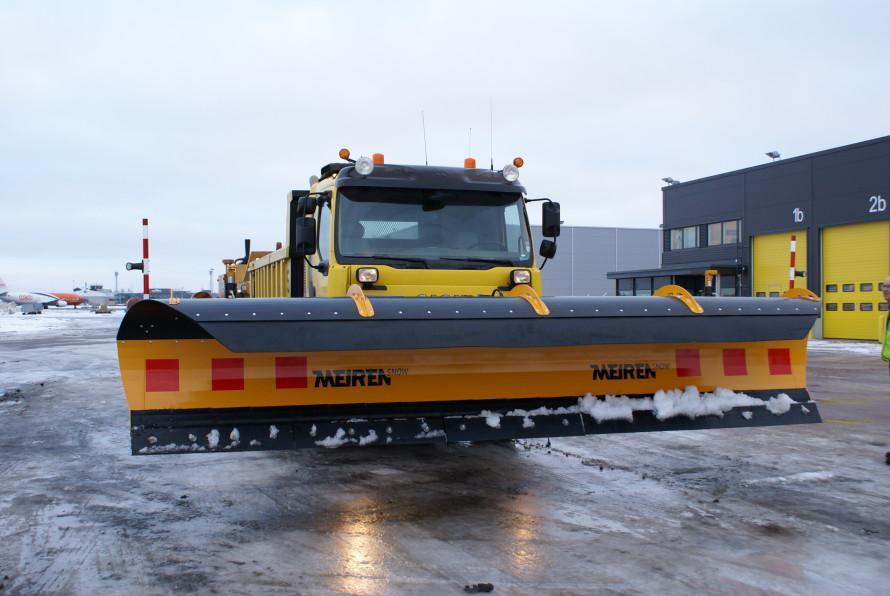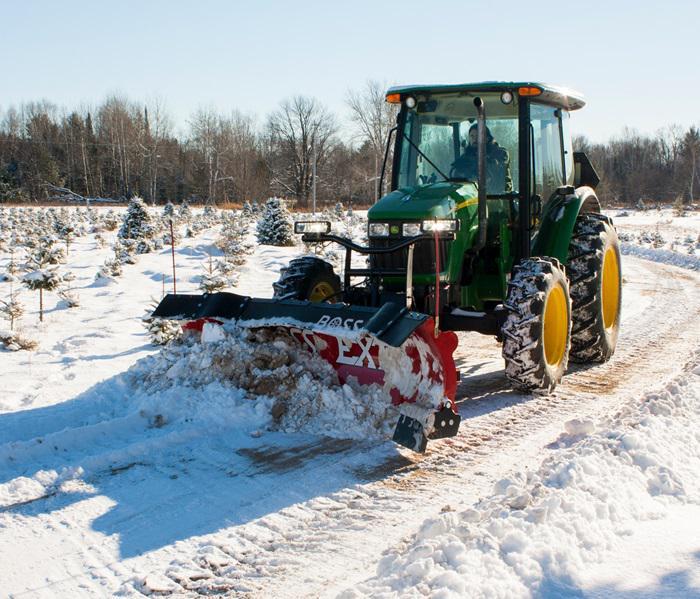The first image is the image on the left, the second image is the image on the right. For the images shown, is this caption "The left and right image contains the same number of snow dump trunks." true? Answer yes or no. No. 